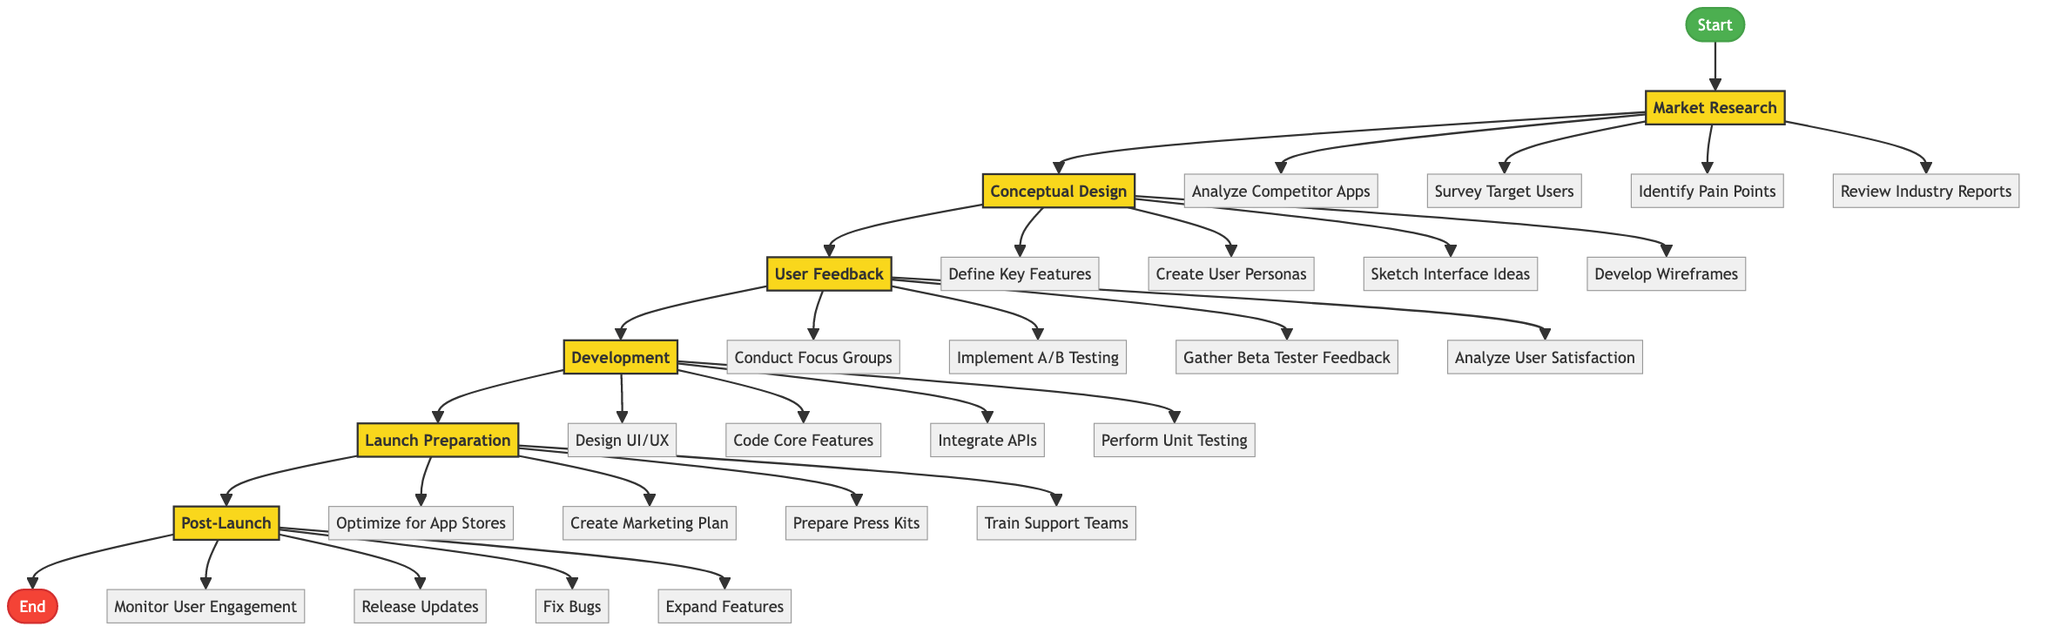What is the first stage in the journey of developing the sports app? The flow chart indicates that the first stage is labeled as "Market Research." This can be determined by following the arrow from the "Start" node, which directly leads to the "Market Research" node.
Answer: Market Research How many actions are there in the "Conceptual Design" stage? From the diagram, the "Conceptual Design" stage is connected to four distinct actions, which are represented as branches leading out from this node. As I count these branches, I find a total of four actions.
Answer: 4 What action comes directly after "Survery Target Users" in the flow chart? Following the flow of the diagram from the "Market Research" stage, the actions flow sequentially. The action that comes directly after "Survey Target Users" is "Identify Pain Points." This is based on the arrangement of the actions in the diagram.
Answer: Identify Pain Points In which stage does "Conduct Focus Groups" occur? By reviewing the flow chart, "Conduct Focus Groups" is linked to the "User Feedback" stage. This is evident because it is one of the action nodes that branches out from the "User Feedback" stage.
Answer: User Feedback How many stages are there in total from "Start" to "End"? The flow chart is structured with six main stages that connect from the "Start" node through to the "End" node. Counting all the stages in this path gives a total of six stages.
Answer: 6 What is the last action listed in the "Post-Launch" stage? By examining the branches that emerge from the "Post-Launch" stage at the end of the flowchart, I can see that "Expand Features" is the final action connected to this stage. This action appears last in the visual structure.
Answer: Expand Features Which stage includes actions related to app optimization and marketing? The stage that includes actions focused on app optimization and marketing is the "Launch Preparation" stage. This can be identified by checking the actions listed beneath this specific node in the flowchart.
Answer: Launch Preparation Name one action listed under the "Development" stage. In the "Development" stage, one of the actions is "Design UI/UX." This can be confirmed by reviewing the actions that branch from the "Development" stage in the diagram.
Answer: Design UI/UX 